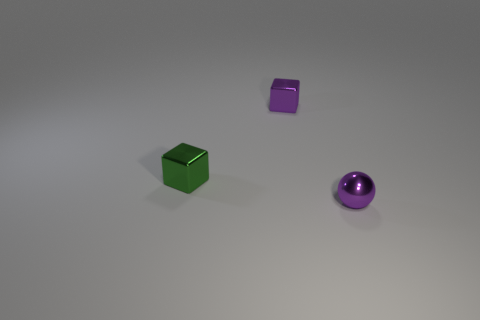Subtract all balls. How many objects are left? 2 Add 3 big blue metal things. How many objects exist? 6 Subtract all purple blocks. How many blocks are left? 1 Subtract all red cubes. Subtract all yellow cylinders. How many cubes are left? 2 Subtract all yellow balls. How many cyan blocks are left? 0 Subtract all green objects. Subtract all tiny green shiny objects. How many objects are left? 1 Add 1 small purple objects. How many small purple objects are left? 3 Add 1 small purple things. How many small purple things exist? 3 Subtract 0 blue cubes. How many objects are left? 3 